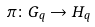<formula> <loc_0><loc_0><loc_500><loc_500>\pi \colon { G } _ { q } \rightarrow H _ { q }</formula> 